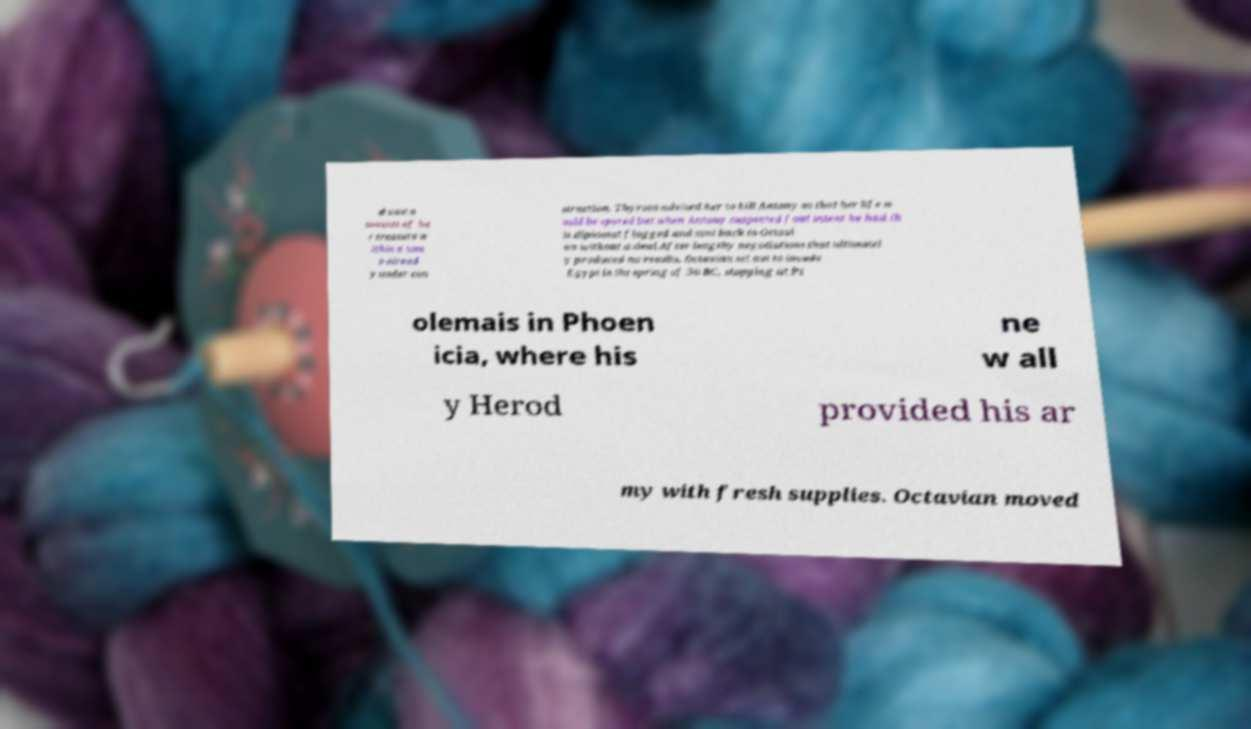Could you assist in decoding the text presented in this image and type it out clearly? d vast a mounts of he r treasure w ithin a tom b alread y under con struction. Thyrsos advised her to kill Antony so that her life w ould be spared but when Antony suspected foul intent he had th is diplomat flogged and sent back to Octavi an without a deal.After lengthy negotiations that ultimatel y produced no results, Octavian set out to invade Egypt in the spring of 30 BC, stopping at Pt olemais in Phoen icia, where his ne w all y Herod provided his ar my with fresh supplies. Octavian moved 